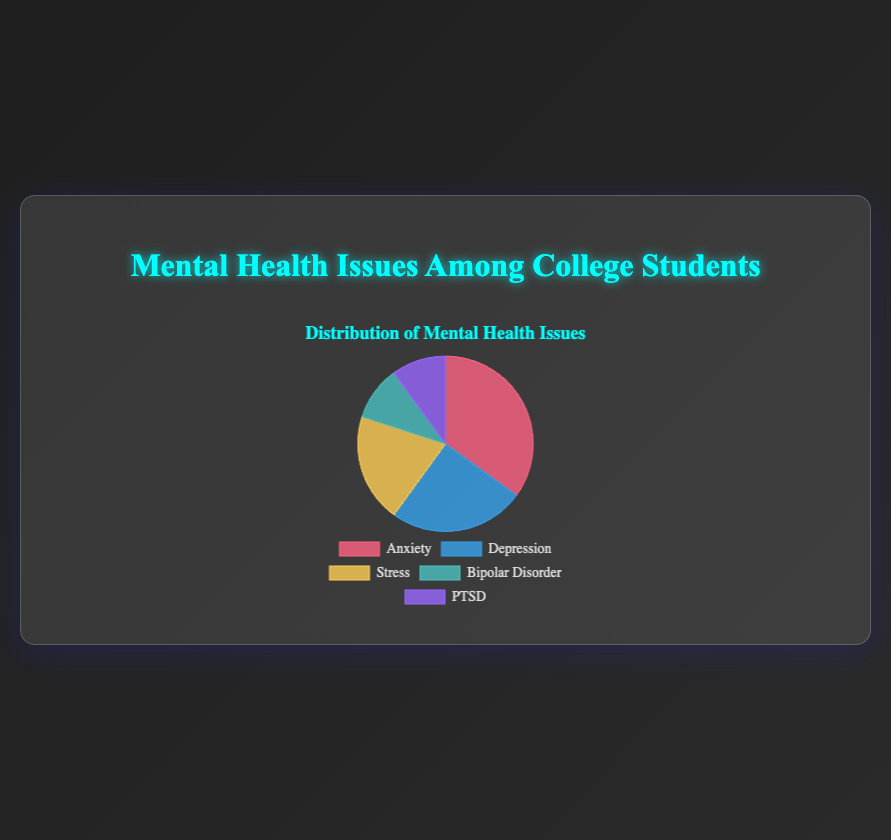What is the most common mental health issue among college students displayed in the pie chart? The pie chart shows different percentages of mental health issues. Anxiety has the highest percentage, which is 35%.
Answer: Anxiety Compare the percentage of students experiencing Depression and Stress. Which one is higher? The pie chart shows percentages for Depression and Stress as 25% and 20%, respectively. Since 25% > 20%, Depression is higher.
Answer: Depression What is the sum of the percentage of students experiencing Bipolar Disorder and PTSD? The pie chart shows that both Bipolar Disorder and PTSD have percentages of 10% each. The sum is 10% + 10% = 20%.
Answer: 20% How much smaller is the percentage of students with Stress compared to those with Anxiety? Anxiety is 35% and Stress is 20%. Subtract the percentage of Stress from Anxiety: 35% - 20% = 15%.
Answer: 15% Which mental health issue is equally prevalent among college students, according to the pie chart? Both Bipolar Disorder and PTSD have the same percentage, which is 10%.
Answer: Bipolar Disorder and PTSD What percentage of students experience issues other than Anxiety? The pie chart indicates Anxiety is 35%. Therefore, the percentage of students experiencing other issues is 100% - 35% = 65%.
Answer: 65% If you combine the students experiencing Anxiety, Depression, and Stress, what is the total percentage? Adding the percentages: Anxiety (35%), Depression (25%), Stress (20%). The total is 35% + 25% + 20% = 80%.
Answer: 80% What is the least common mental health issue among the students shown in the pie chart? The pie chart indicates that the least common issues, with the lowest percentages, are Bipolar Disorder and PTSD, both at 10%.
Answer: Bipolar Disorder and PTSD 